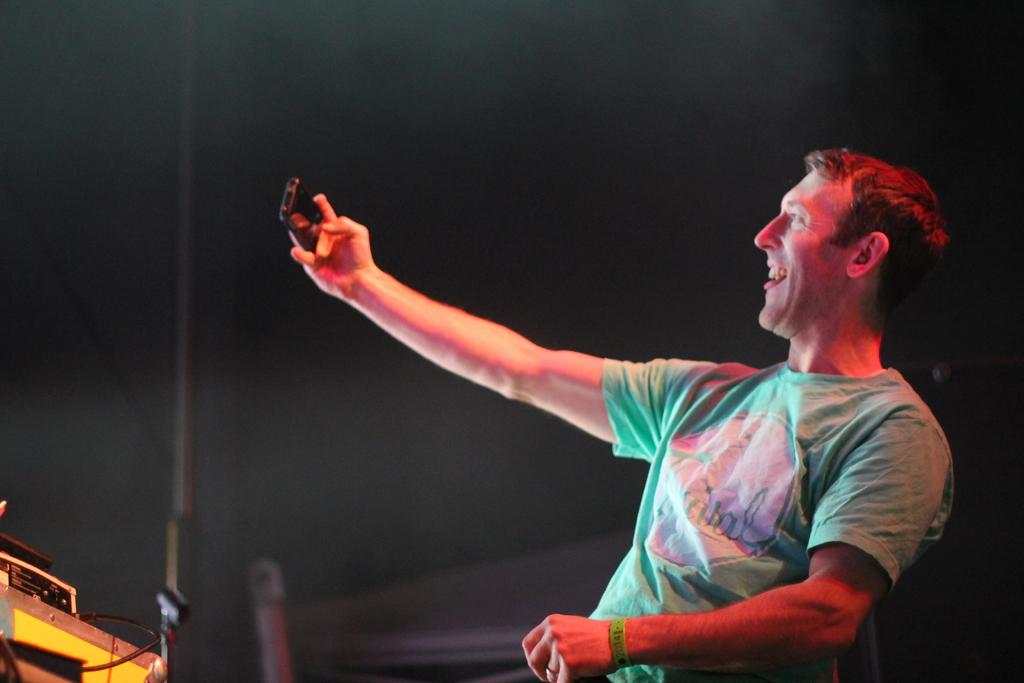What is the main subject of the image? There is a person in the image. What is the person doing in the image? The person is smiling. What object is the person holding in the image? The person is holding a mobile. What can be observed about the background of the image? The background of the image is dark. What type of tree can be seen in the image? There is no tree present in the image. What is the name of the person in the image? The name of the person in the image is not mentioned in the provided facts. 